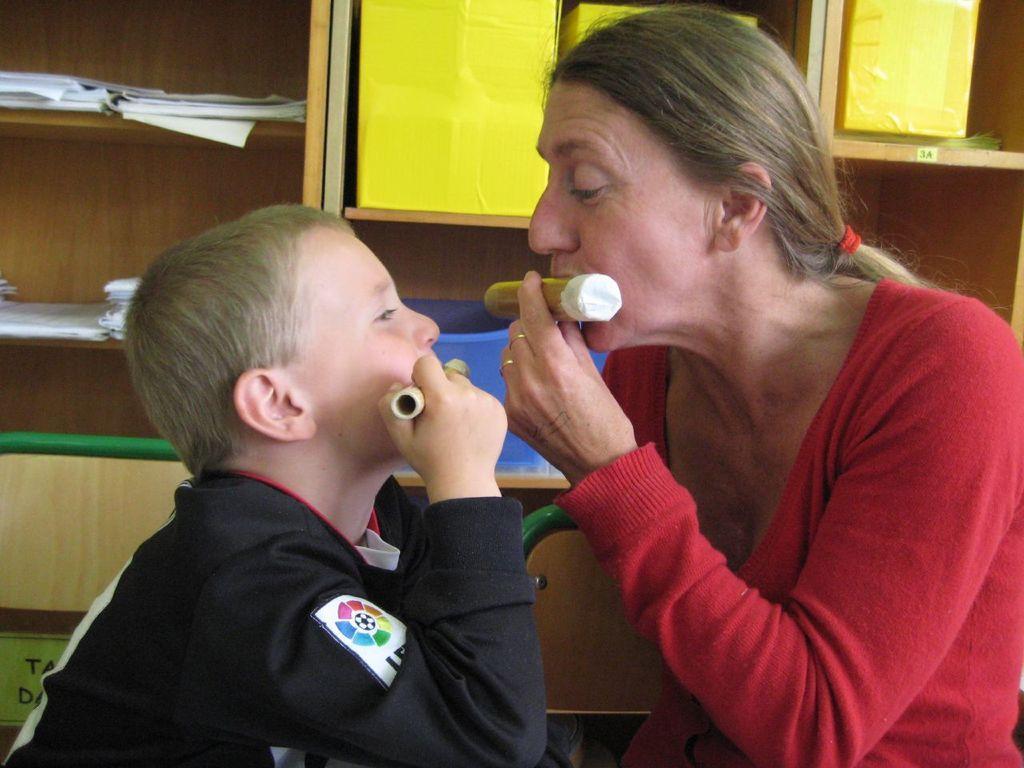Could you give a brief overview of what you see in this image? In the picture we can see a woman and a boy sitting and holding something near the mouth and watching each other faces and in the background, we can see some racks with some papers and some boxes which are yellow in color. 